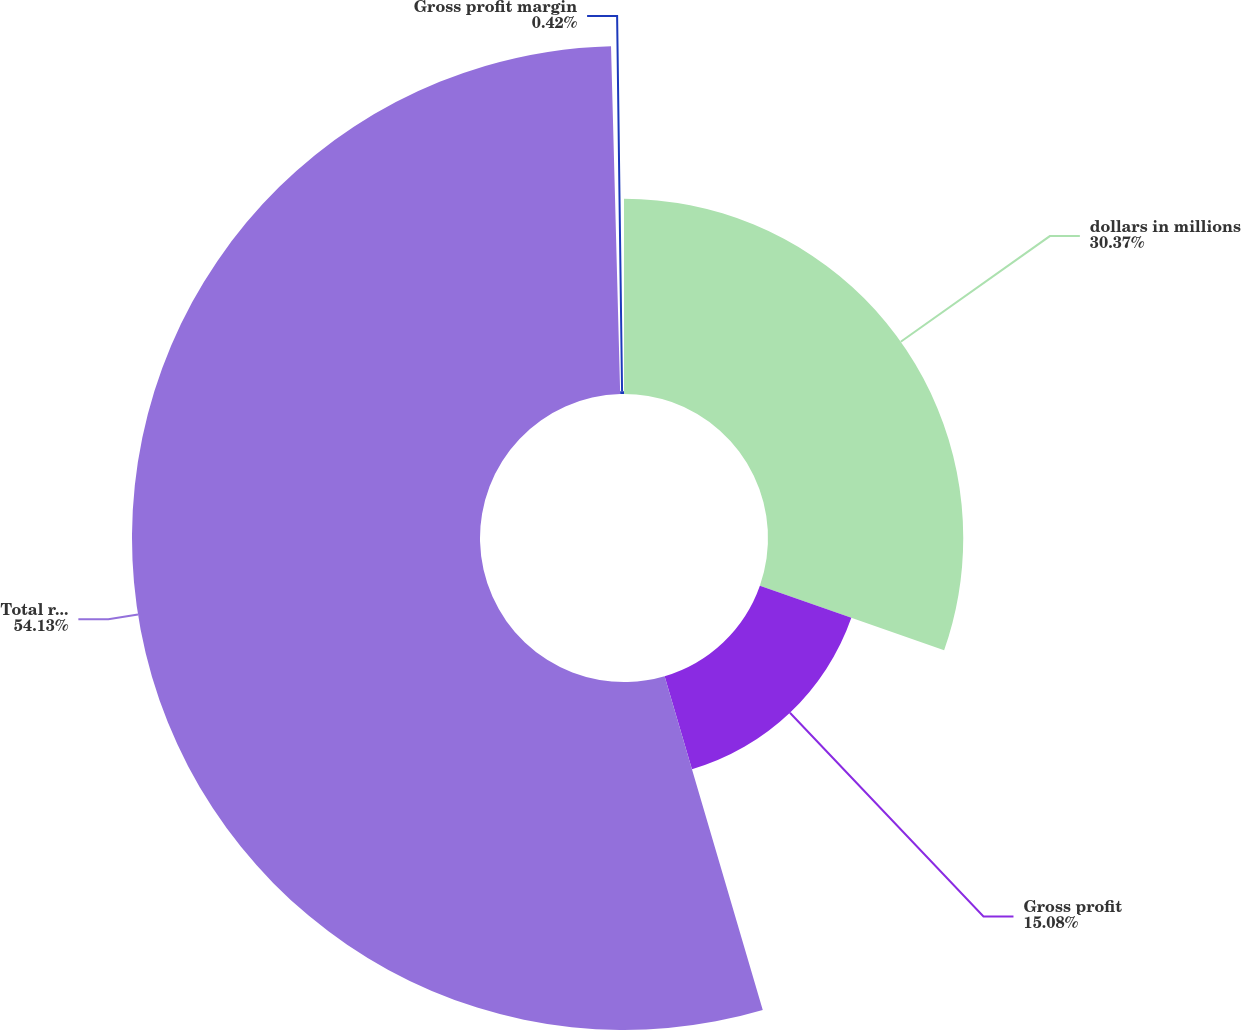Convert chart to OTSL. <chart><loc_0><loc_0><loc_500><loc_500><pie_chart><fcel>dollars in millions<fcel>Gross profit<fcel>Total revenues<fcel>Gross profit margin<nl><fcel>30.37%<fcel>15.08%<fcel>54.13%<fcel>0.42%<nl></chart> 